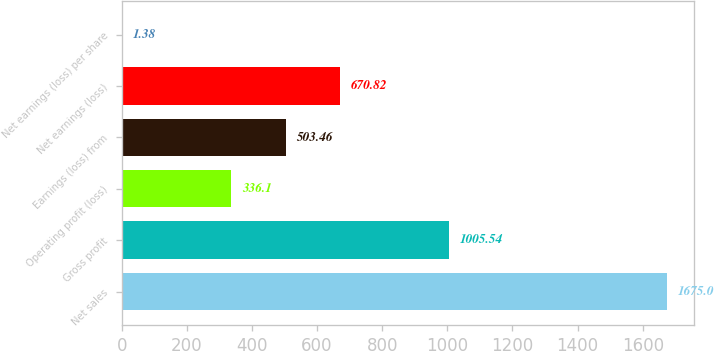Convert chart to OTSL. <chart><loc_0><loc_0><loc_500><loc_500><bar_chart><fcel>Net sales<fcel>Gross profit<fcel>Operating profit (loss)<fcel>Earnings (loss) from<fcel>Net earnings (loss)<fcel>Net earnings (loss) per share<nl><fcel>1675<fcel>1005.54<fcel>336.1<fcel>503.46<fcel>670.82<fcel>1.38<nl></chart> 